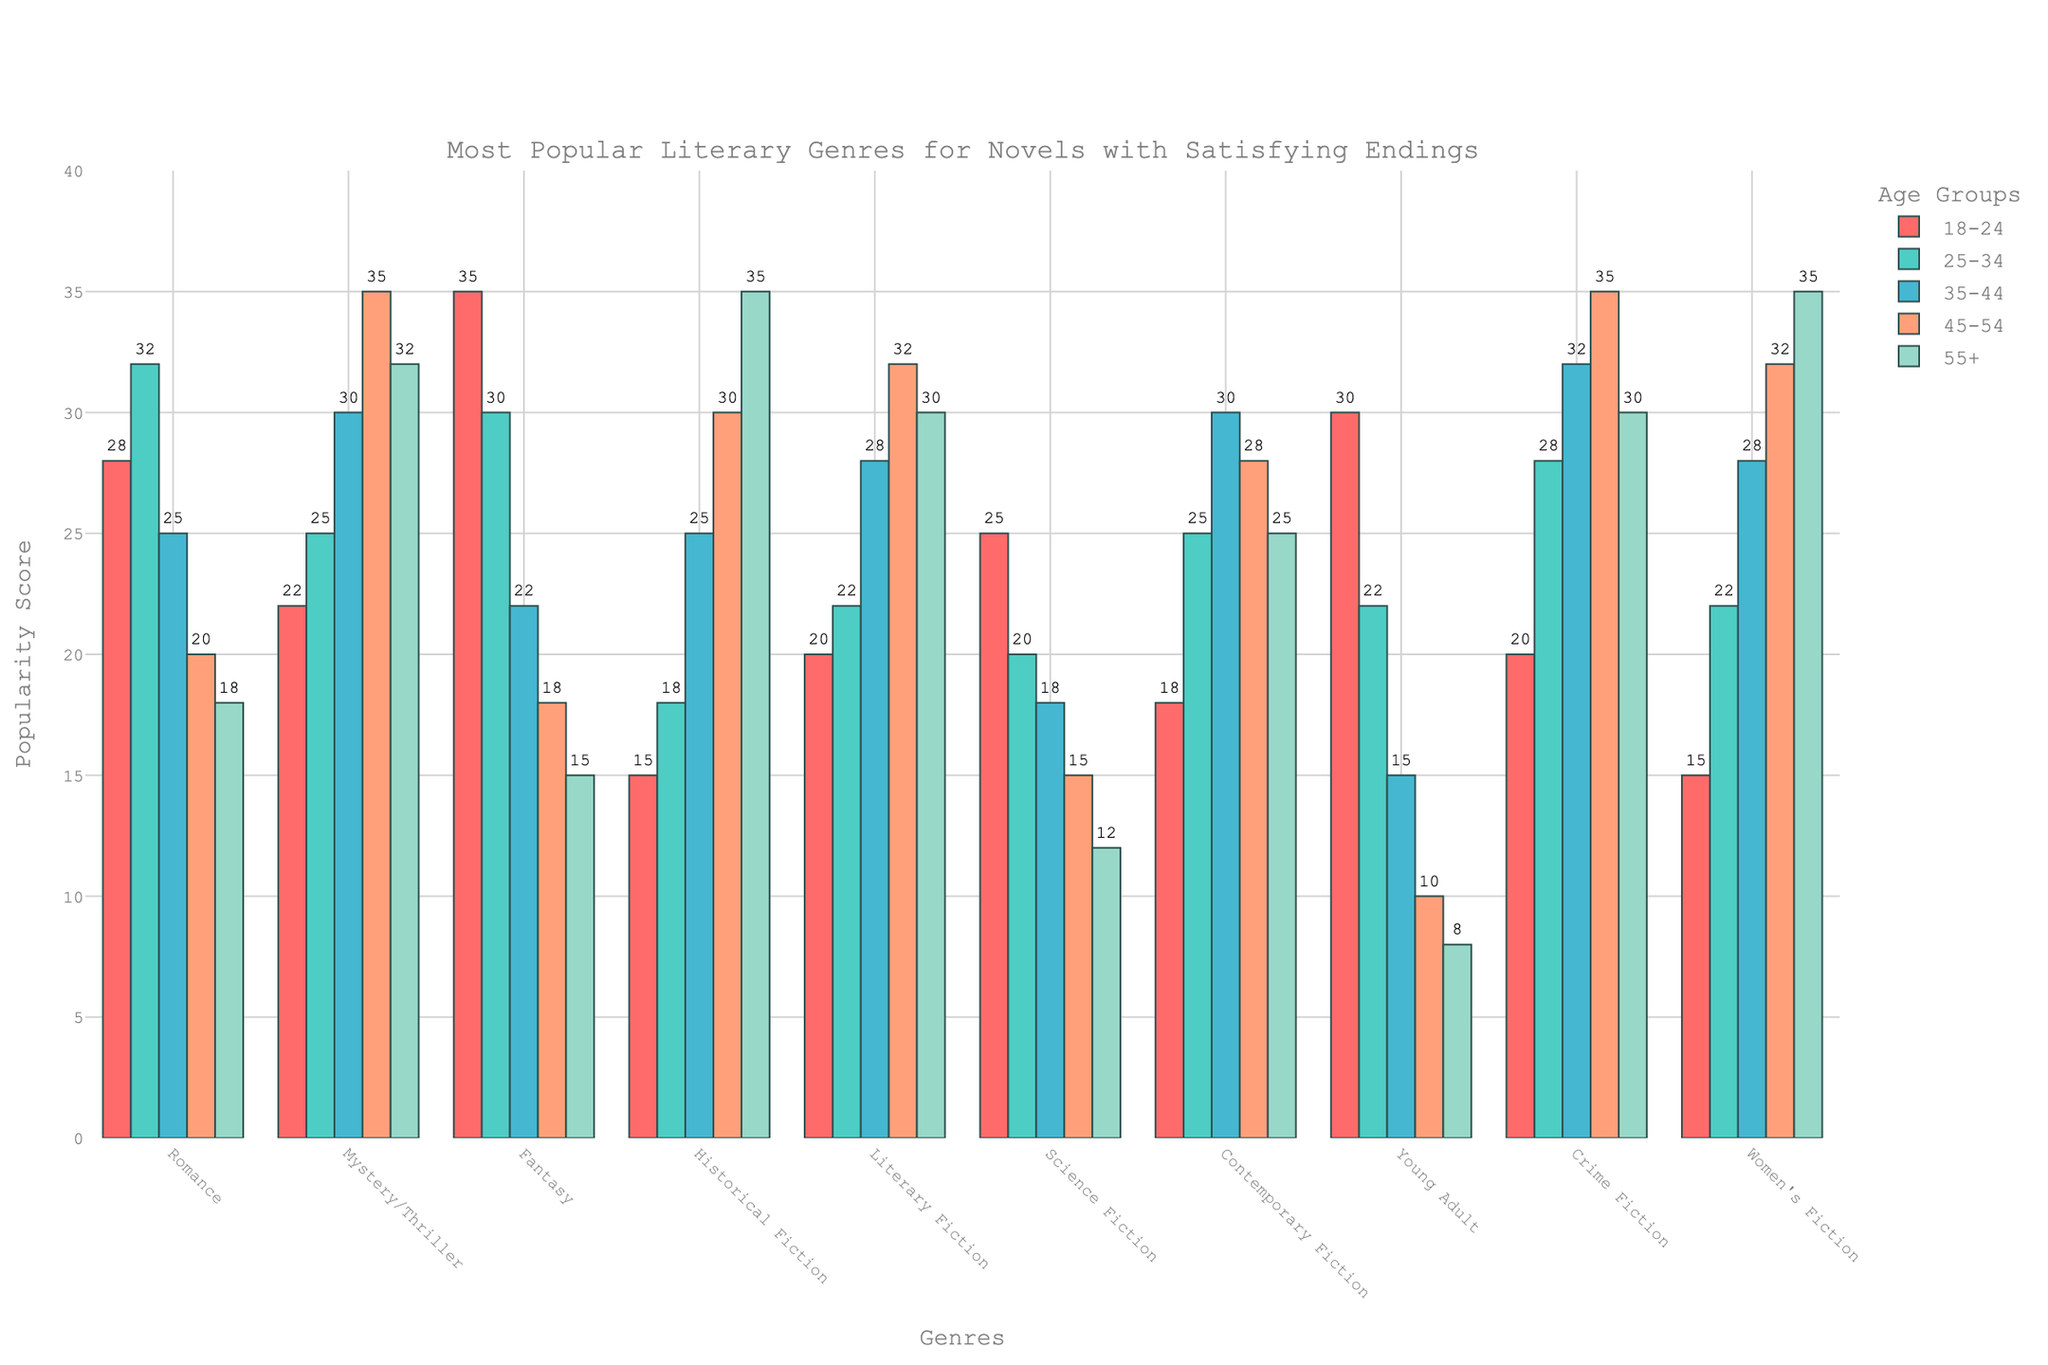Among readers aged 25-34, which genre shows the highest popularity? Looking at the vertical bars for the age group 25-34, the tallest bar corresponds to the "Romance" genre. This indicates that Romance has the highest popularity in this age group.
Answer: Romance What's the total popularity score for Romance novels across all age groups? We sum up the values for "Romance" across all age groups: 28 + 32 + 25 + 20 + 18 = 123.
Answer: 123 How does the popularity of Fantasy among 18-24 year-olds compare to the popularity of Historical Fiction among 45-54 year-olds? The value for "Fantasy" in the 18-24 age group is 35, and the value for "Historical Fiction" in the 45-54 age group is also 35. Both have the same popularity score of 35.
Answer: Equal Between the age groups 35-44 and 55+, which one shows greater interest in Science Fiction? Comparing the bars for Science Fiction, we see that the bar for 35-44 is taller than 55+, with values 18 and 12 respectively. Therefore, interest is higher among the 35-44 age group.
Answer: 35-44 What is the average popularity score for Literary Fiction across the 18-34 age groups? The average can be calculated by summing up the popularity scores for Literary Fiction in the 18-24, 25-34, and 35-44 age groups and dividing by the number of groups: (20 + 22 + 28)/3 = 70/3 ≈ 23.33.
Answer: ≈ 23.33 Which genre has a consistent increase in popularity as reader age increases? By inspecting the bar heights for each genre across increasing age groups, we see that "Historical Fiction" shows a consistent increase in popularity from younger to older age groups.
Answer: Historical Fiction 